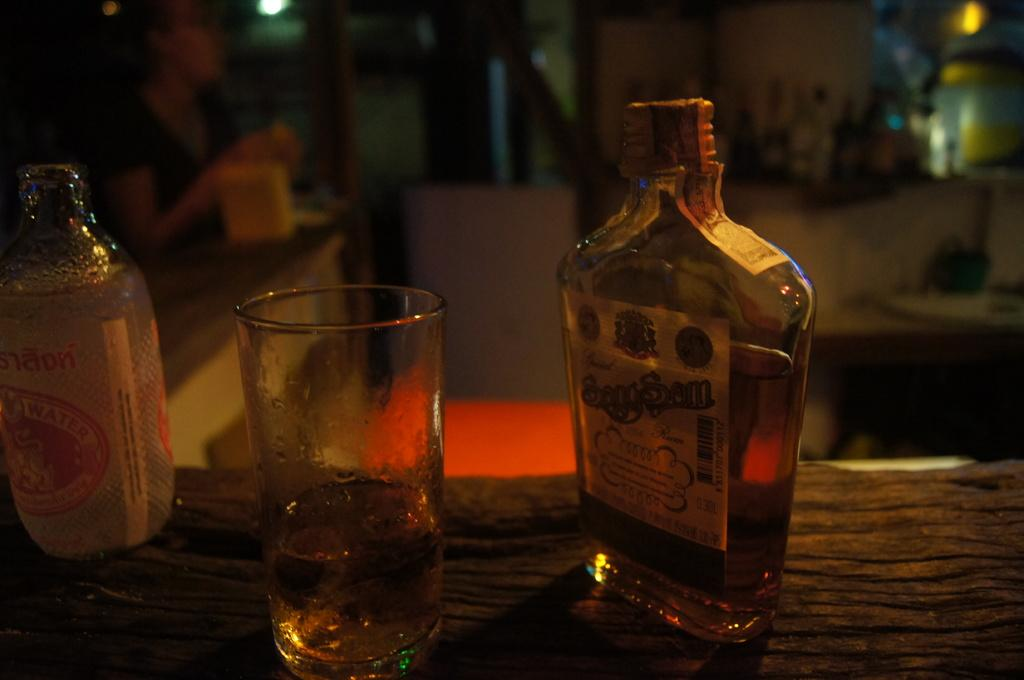What is located on the right side of the image? There is a wine bottle and a glass on the table on the right side of the image. Can you describe the woman in the image? The woman is in the top left corner of the image. What type of angle can be seen in the image? There is no specific angle mentioned or depicted in the image. Is there a lake visible in the image? There is no lake present in the image. 